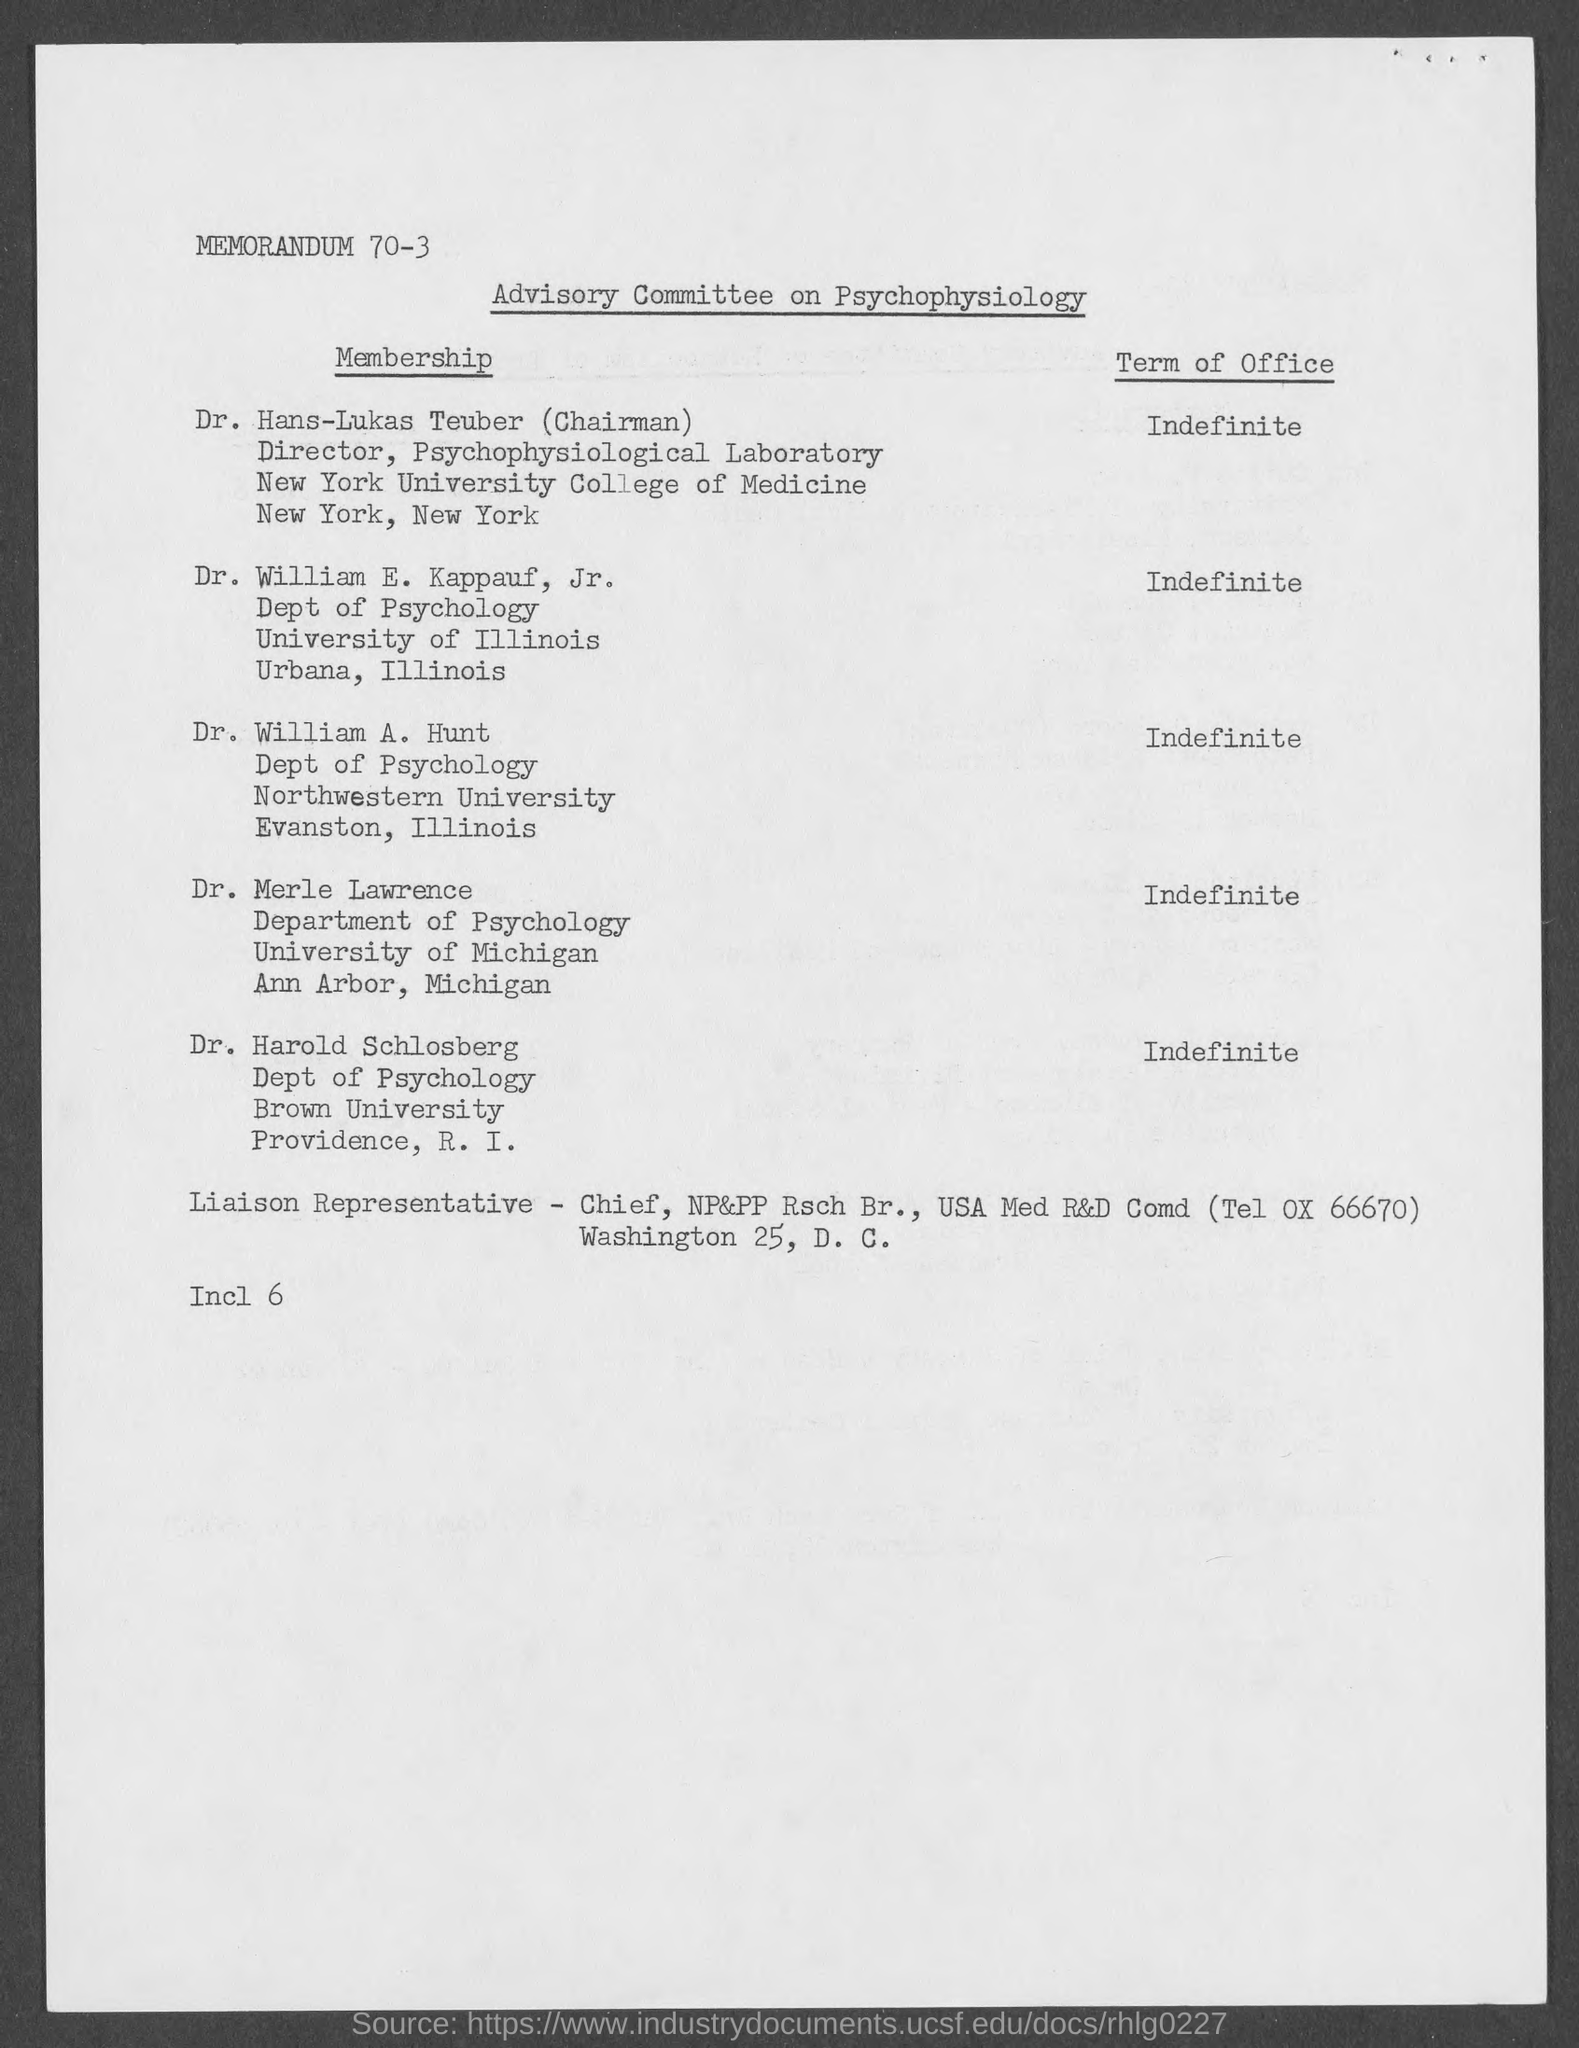Outline some significant characteristics in this image. The Advisory Committee on Psychophysiology is known as "What is the name of the Committee?". 